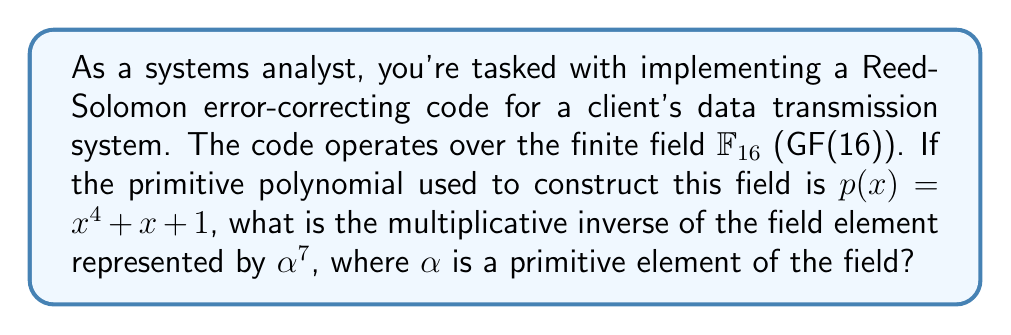Help me with this question. Let's approach this step-by-step:

1) In $\mathbb{F}_{16}$, there are 15 non-zero elements, represented as powers of $\alpha$ from $\alpha^0$ to $\alpha^{14}$.

2) The multiplicative group of $\mathbb{F}_{16}$ is cyclic of order 15. This means that $\alpha^{15} = 1$.

3) For any element $\alpha^k$ in the field, its multiplicative inverse is $\alpha^{-k} = \alpha^{15-k}$.

4) In our case, we need to find the inverse of $\alpha^7$.

5) Using the property from step 3:
   $(\alpha^7)^{-1} = \alpha^{15-7} = \alpha^8$

6) To verify:
   $\alpha^7 \cdot \alpha^8 = \alpha^{15} = 1$

Therefore, the multiplicative inverse of $\alpha^7$ is $\alpha^8$.
Answer: $\alpha^8$ 